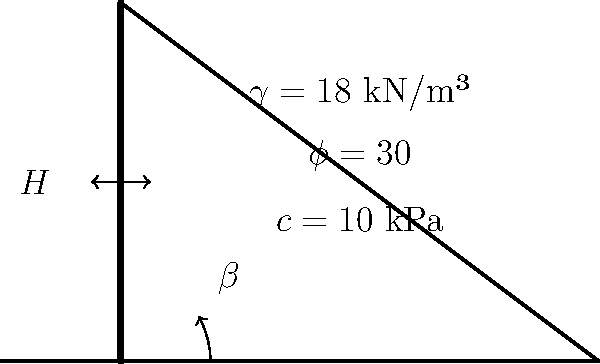A terraced agricultural plot requires a retaining wall to support the backfill. Given the following soil properties and conditions:

- Unit weight of soil ($\gamma$) = 18 kN/m³
- Angle of internal friction ($\phi$) = 30°
- Cohesion ($c$) = 10 kPa
- Backfill angle ($\beta$) = 20°
- Factor of safety against overturning = 2.0

Calculate the maximum safe height ($H$) of the retaining wall using Rankine's theory for active earth pressure. Assume the wall is vertical and smooth. To determine the safe height of the retaining wall, we'll follow these steps:

1) First, calculate the active earth pressure coefficient ($K_a$) using Rankine's theory:

   $K_a = \cos\beta \frac{\cos\beta - \sqrt{\cos^2\beta - \cos^2\phi}}{\cos\beta + \sqrt{\cos^2\beta - \cos^2\phi}}$

   $K_a = \cos(20°) \frac{\cos(20°) - \sqrt{\cos^2(20°) - \cos^2(30°)}}{\cos(20°) + \sqrt{\cos^2(20°) - \cos^2(30°)}} = 0.3391$

2) Calculate the total active thrust ($P_a$) per unit length of the wall:

   $P_a = \frac{1}{2} \gamma H^2 K_a - 2c H \sqrt{K_a}$

3) The moment of this thrust about the toe of the wall is:

   $M = P_a \cdot \frac{H}{3} = (\frac{1}{2} \gamma H^2 K_a - 2c H \sqrt{K_a}) \cdot \frac{H}{3}$

4) The resisting moment is provided by the weight of the wall. Assuming a unit thickness and that the wall is made of concrete (density ≈ 24 kN/m³):

   $M_r = \frac{1}{2} \cdot 24 \cdot H^2 \cdot \frac{H}{3} = 4H^3$

5) For stability against overturning, we need:

   $\frac{M_r}{M} \geq 2.0$ (given factor of safety)

6) Substituting and solving the equation:

   $\frac{4H^3}{(\frac{1}{2} \cdot 18 \cdot H^2 \cdot 0.3391 - 2 \cdot 10 \cdot H \cdot \sqrt{0.3391}) \cdot \frac{H}{3}} \geq 2.0$

7) Simplifying and solving for $H$:

   $4H^3 \geq 2 \cdot (\frac{1}{2} \cdot 18 \cdot H^2 \cdot 0.3391 - 2 \cdot 10 \cdot H \cdot \sqrt{0.3391}) \cdot \frac{H}{3}$

   $12 \geq 6.0438H - 7.7304$

   $19.7304 \geq 6.0438H$

   $H \leq 3.26$ m

Therefore, the maximum safe height of the retaining wall is approximately 3.26 meters.
Answer: 3.26 meters 